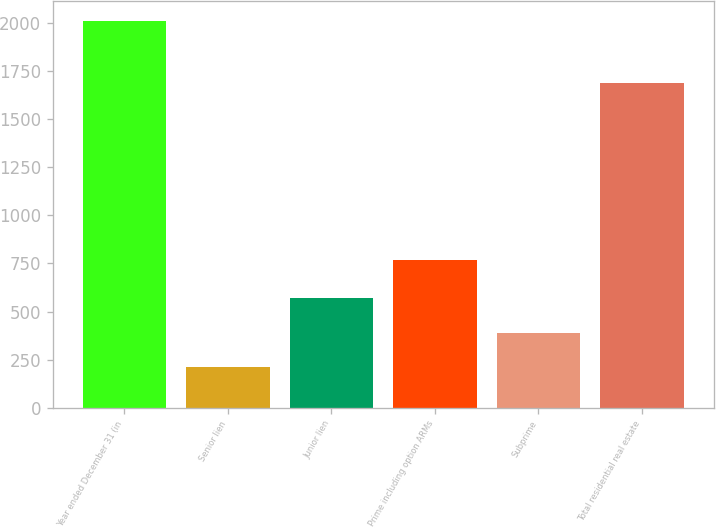Convert chart to OTSL. <chart><loc_0><loc_0><loc_500><loc_500><bar_chart><fcel>Year ended December 31 (in<fcel>Senior lien<fcel>Junior lien<fcel>Prime including option ARMs<fcel>Subprime<fcel>Total residential real estate<nl><fcel>2013<fcel>210<fcel>570.6<fcel>770<fcel>390.3<fcel>1687<nl></chart> 